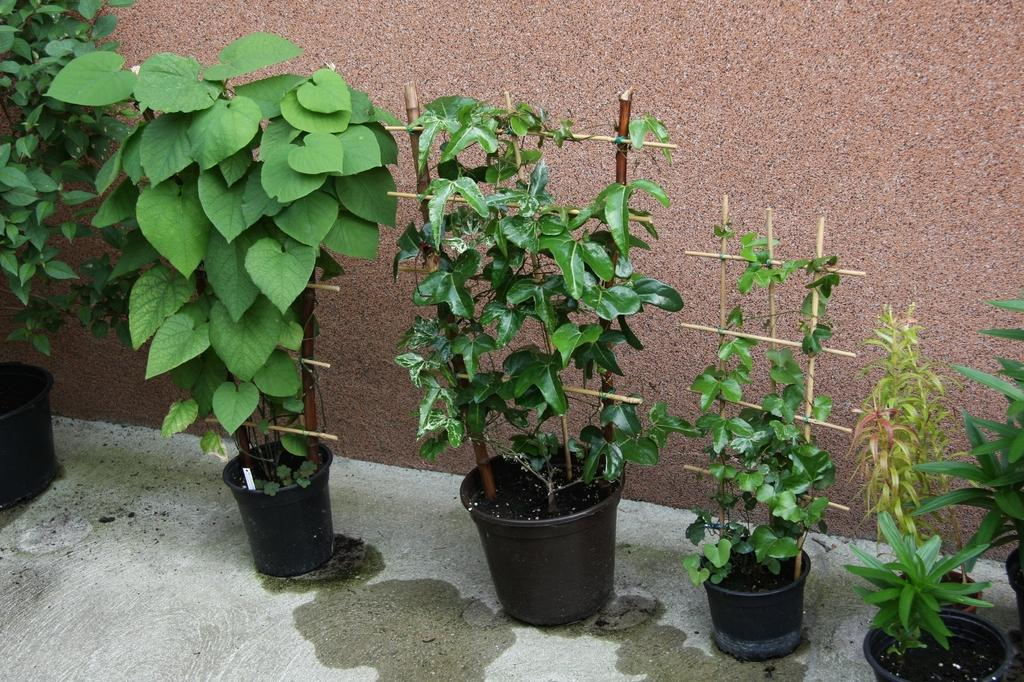What type of plants can be seen in the image? There are pot plants arranged on the floor. Can you describe the background of the image? There is a wall in the background of the image. What type of dust can be seen floating in the air in the image? There is no dust visible in the image. Is there any smoke present in the image? There is no smoke present in the image. Can you describe any conversations or talks happening in the image? There is no indication of any conversations or talks happening in the image. 